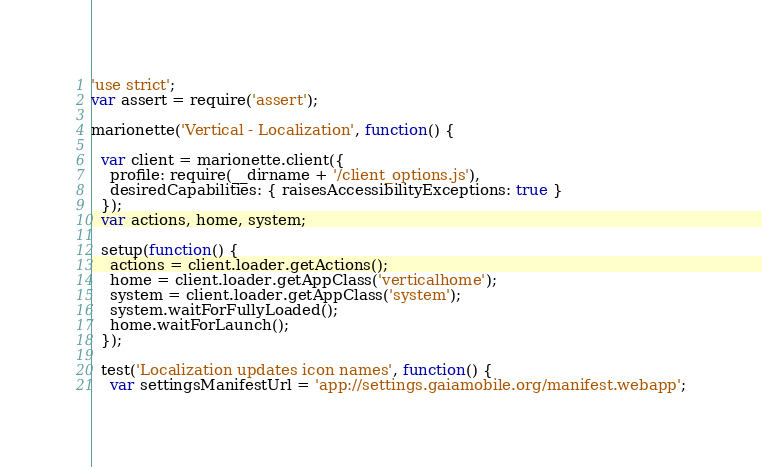Convert code to text. <code><loc_0><loc_0><loc_500><loc_500><_JavaScript_>'use strict';
var assert = require('assert');

marionette('Vertical - Localization', function() {

  var client = marionette.client({
    profile: require(__dirname + '/client_options.js'),
    desiredCapabilities: { raisesAccessibilityExceptions: true }
  });
  var actions, home, system;

  setup(function() {
    actions = client.loader.getActions();
    home = client.loader.getAppClass('verticalhome');
    system = client.loader.getAppClass('system');
    system.waitForFullyLoaded();
    home.waitForLaunch();
  });

  test('Localization updates icon names', function() {
    var settingsManifestUrl = 'app://settings.gaiamobile.org/manifest.webapp';</code> 